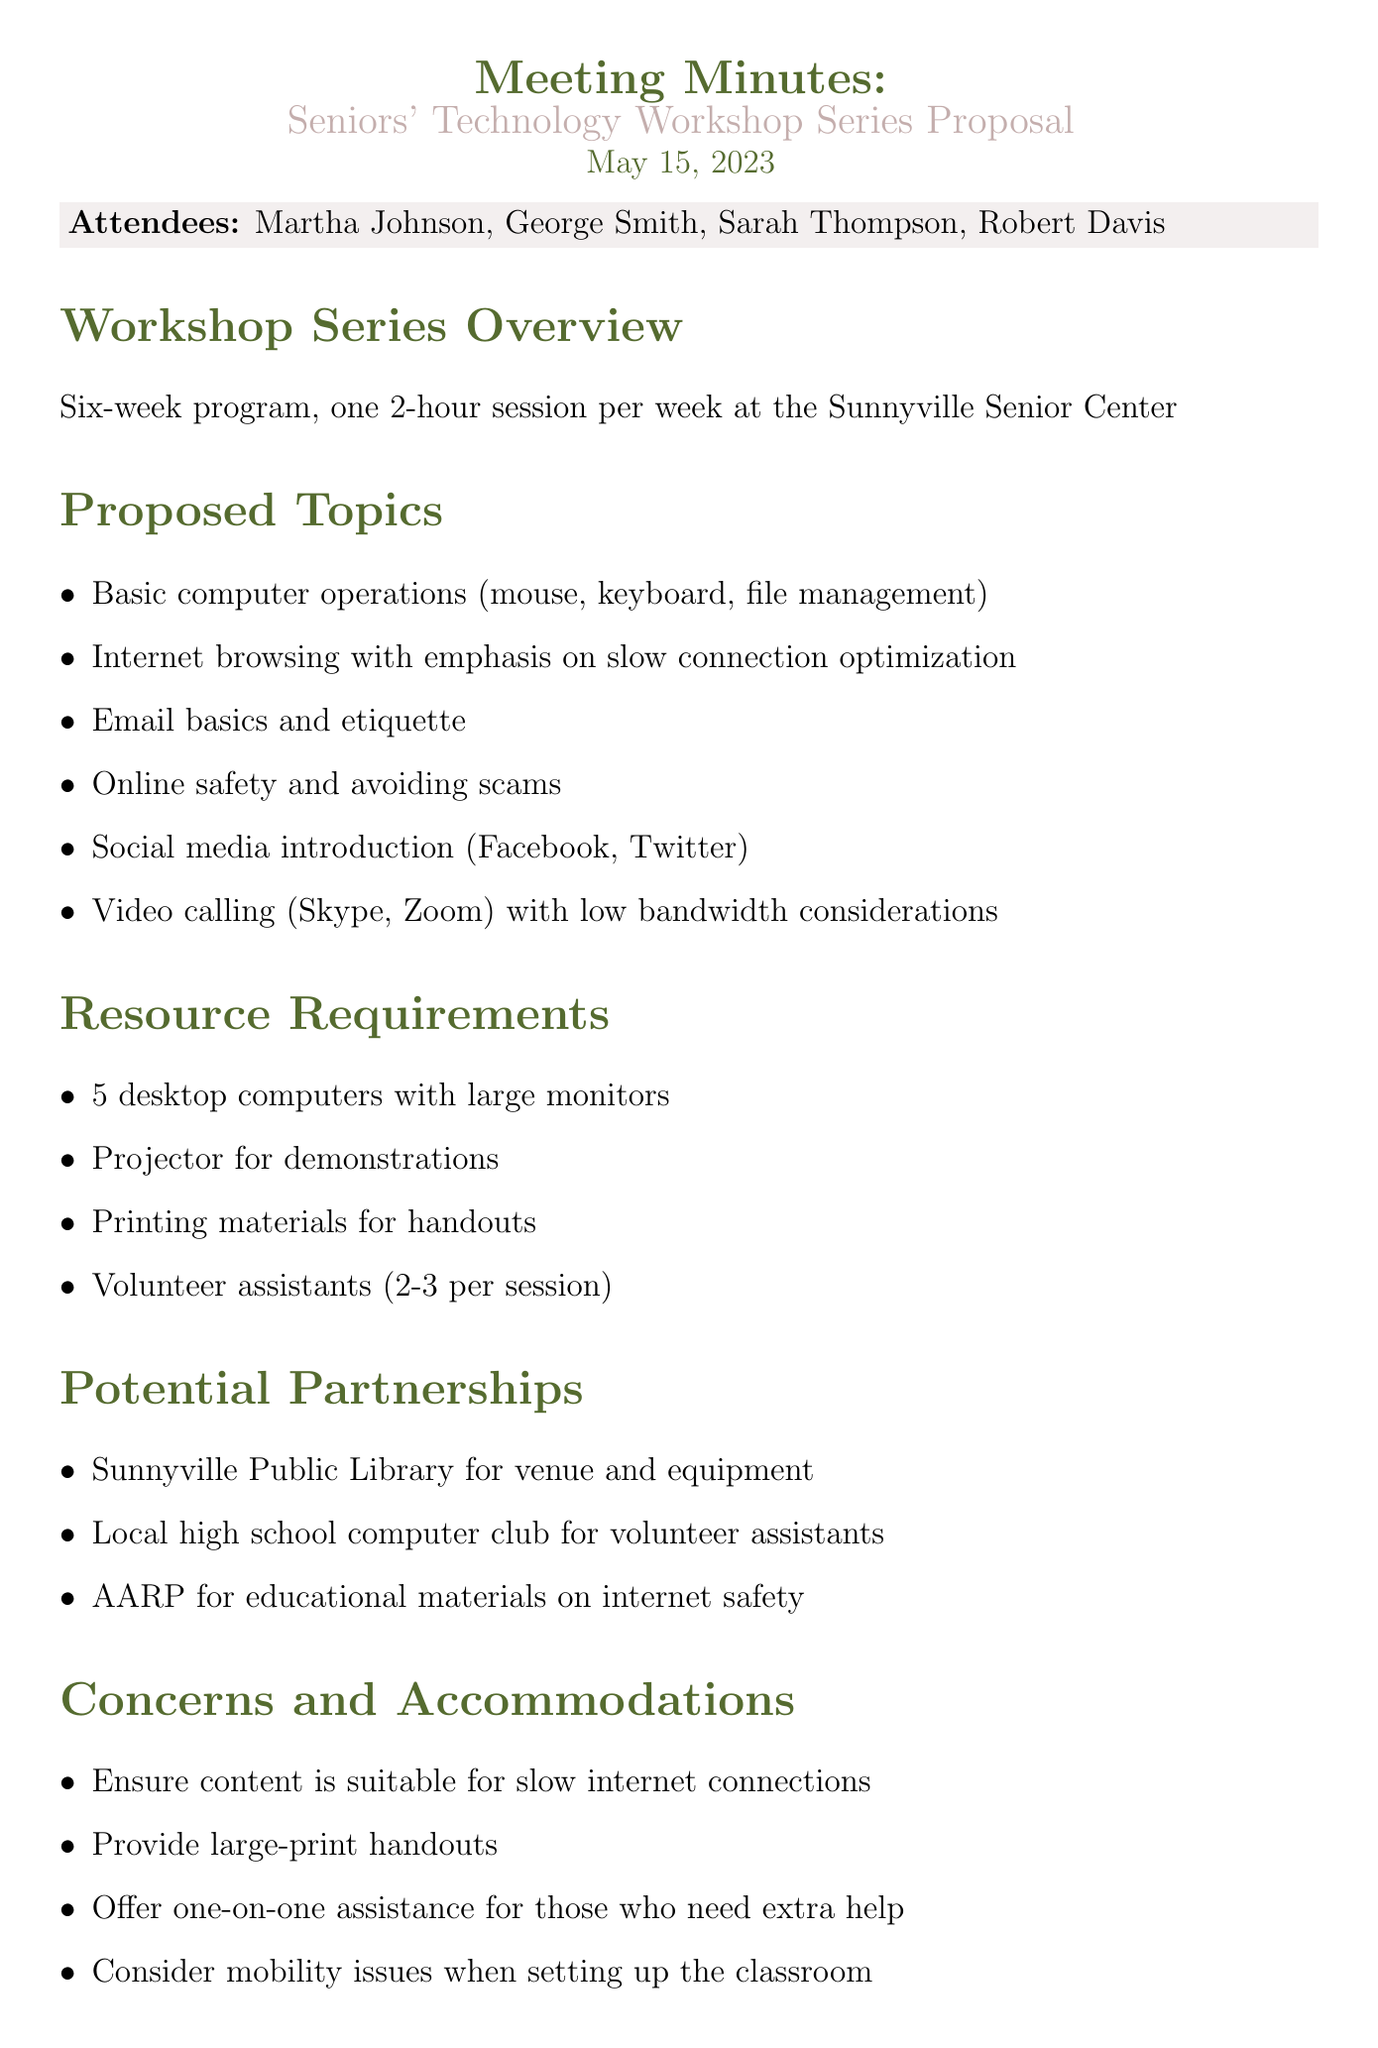What is the meeting date? The meeting date is clearly stated in the document as May 15, 2023.
Answer: May 15, 2023 Who is the Local Library IT Specialist? The document lists attendees, identifying George Smith as the Local Library IT Specialist.
Answer: George Smith How many sessions will the workshop series have? The overview indicates that there will be a six-week program with one session per week.
Answer: Six What is one of the proposed topics for the workshop? The proposed topics include basic computer operations listed in the document.
Answer: Basic computer operations What assistance will be offered to participants who need extra help? The document states that one-on-one assistance will be provided for those needing extra help.
Answer: One-on-one assistance Which organization is mentioned for educational materials on internet safety? AARP is referred to in the document as providing educational materials.
Answer: AARP How many volunteer assistants are required per session? The resource requirements specify that 2-3 volunteer assistants will be needed for each session.
Answer: 2-3 What is the primary venue for the workshop series? The document mentions the Sunnyville Senior Center as the location for the sessions.
Answer: Sunnyville Senior Center What will be prepared for local senior communities? The document states that promotional materials will be prepared for local senior communities.
Answer: Promotional materials 